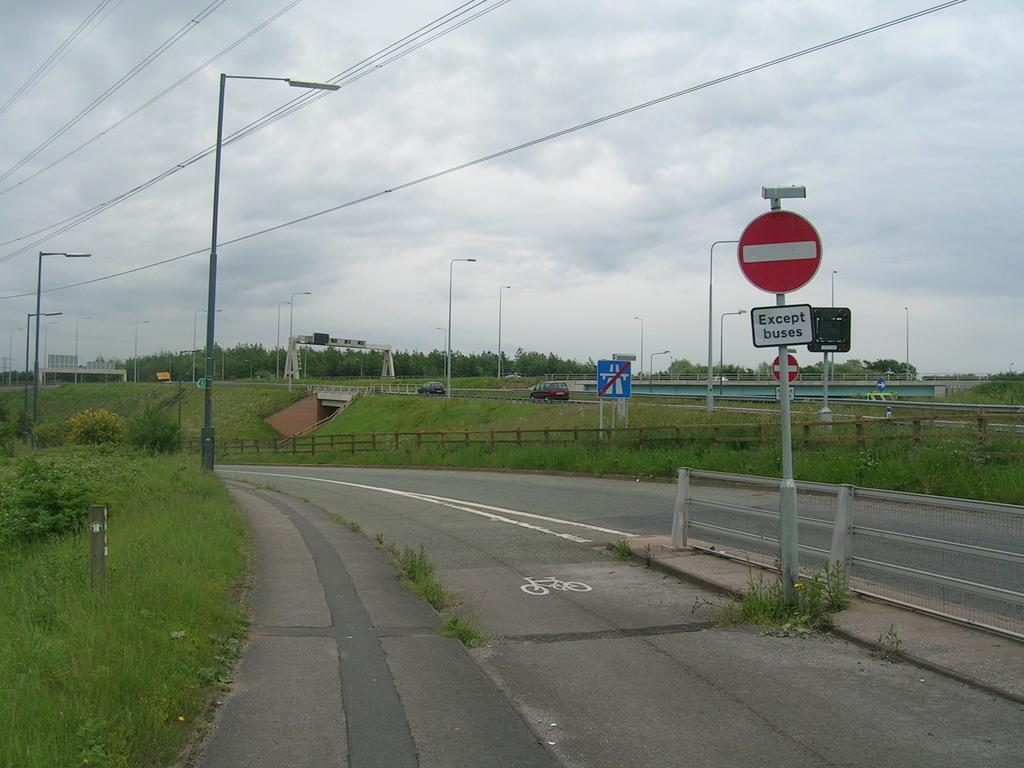<image>
Share a concise interpretation of the image provided. A deserted road near a farm with a no entry colored sign 